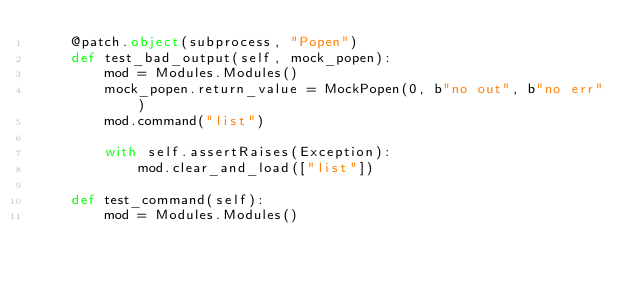Convert code to text. <code><loc_0><loc_0><loc_500><loc_500><_Python_>    @patch.object(subprocess, "Popen")
    def test_bad_output(self, mock_popen):
        mod = Modules.Modules()
        mock_popen.return_value = MockPopen(0, b"no out", b"no err")
        mod.command("list")

        with self.assertRaises(Exception):
            mod.clear_and_load(["list"])

    def test_command(self):
        mod = Modules.Modules()</code> 